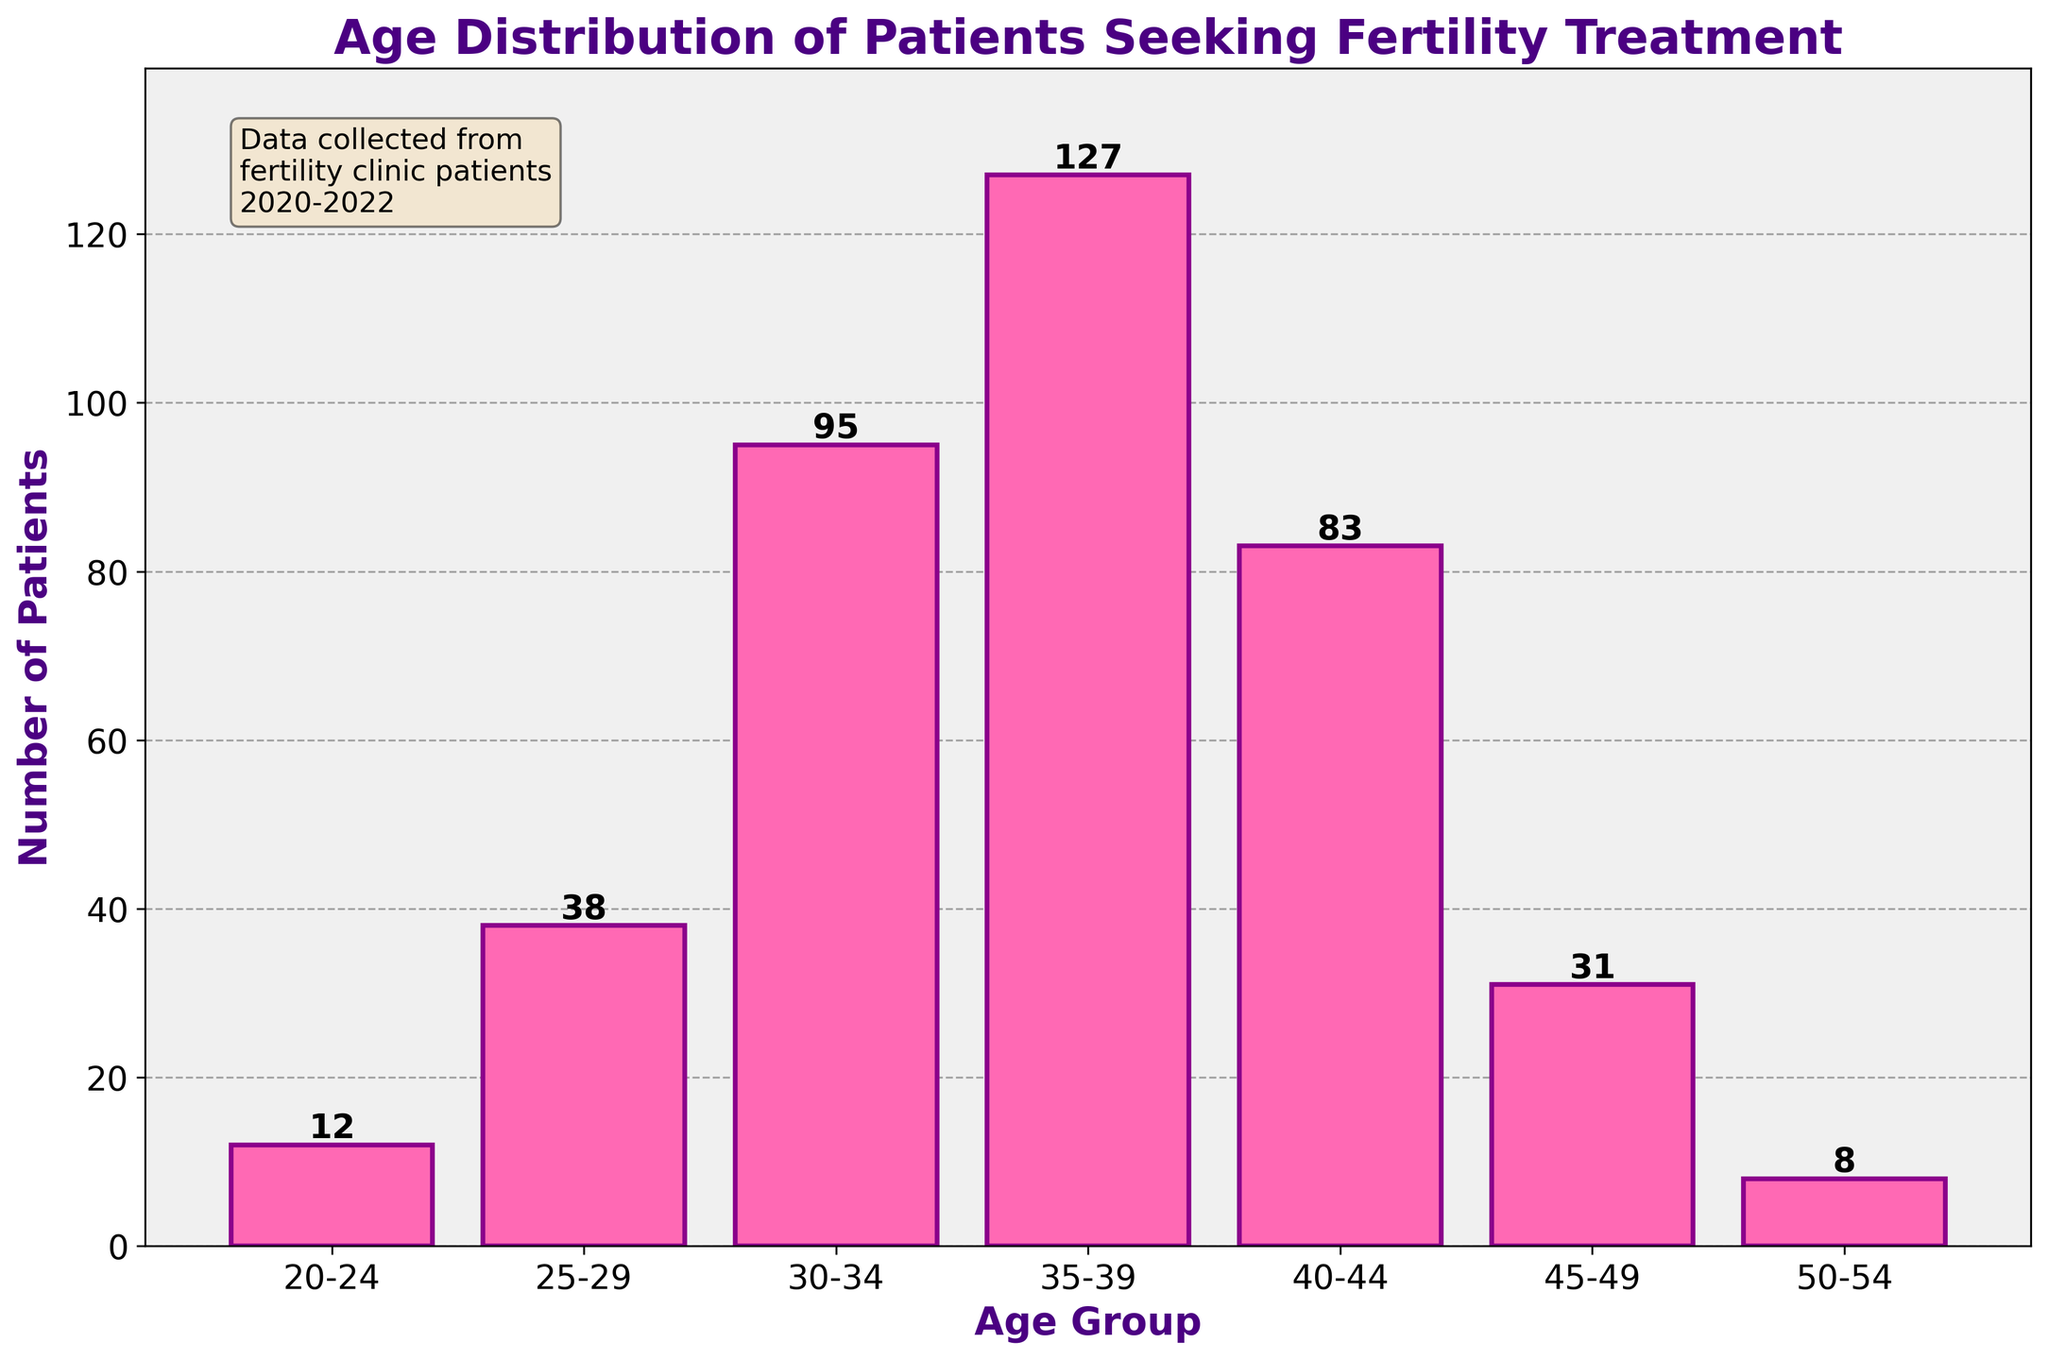What is the title of the histogram? The title of the histogram is written at the top of the figure in large, bold, purple text.
Answer: Age Distribution of Patients Seeking Fertility Treatment What is the age group with the highest frequency of patients? The age group with the tallest bar represents the highest frequency. We see that the age group 35-39 has the highest bar.
Answer: 35-39 How many patients are there in the age group 40-44? The bar corresponding to the age group 40-44 has a value label at the top. According to the label, it is 83.
Answer: 83 Which age group has fewer patients, 20-24 or 45-49? Compare the heights of the bars for age groups 20-24 and 45-49, or check the value labels on top of each bar. The age group 20-24 has 12 patients, and 45-49 has 31 patients.
Answer: 20-24 How many more patients are there in the age group 35-39 than in the age group 30-34? Subtract the number of patients in the age group 30-34 (95) from those in the age group 35-39 (127). So, 127 - 95 = 32.
Answer: 32 What is the total number of patients represented in the histogram? Add the number of patients in each age group together: 12 (20-24) + 38 (25-29) + 95 (30-34) + 127 (35-39) + 83 (40-44) + 31 (45-49) + 8 (50-54). This gives us 12 + 38 + 95 + 127 + 83 + 31 + 8 = 394.
Answer: 394 Which age group has the second-highest number of patients? Identify the second tallest bar after the tallest. The tallest bar is for 35-39, and the second tallest bar is for 30-34.
Answer: 30-34 Is there a noticeable trend in the frequency of patients as age increases? Observing the heights of the bars from left to right, we see an initial increase up to the age group 35-39, followed by a decrease in the subsequent age groups.
Answer: Yes, a rise and then a fall What is the combined number of patients in the age groups 30-34 and 40-44? Add the number of patients in the age group 30-34 (95) and age group 40-44 (83). So, 95 + 83 = 178.
Answer: 178 